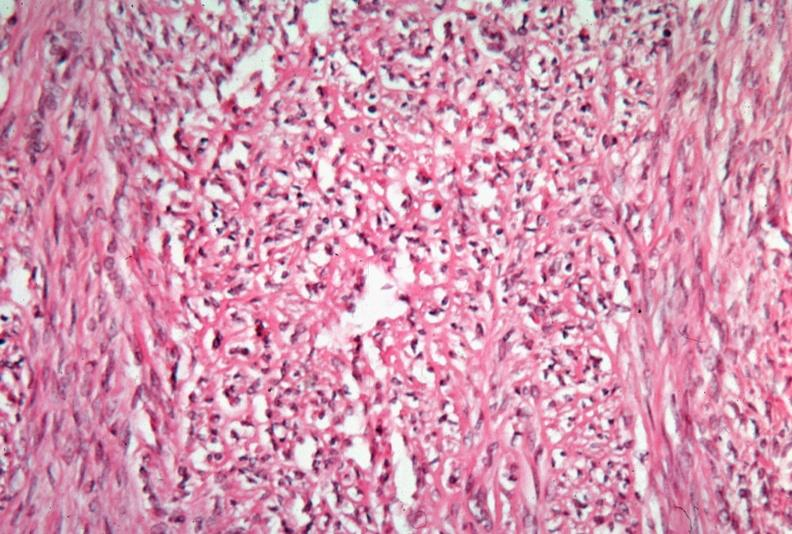does hematoma show uterus, leiomyoma?
Answer the question using a single word or phrase. No 